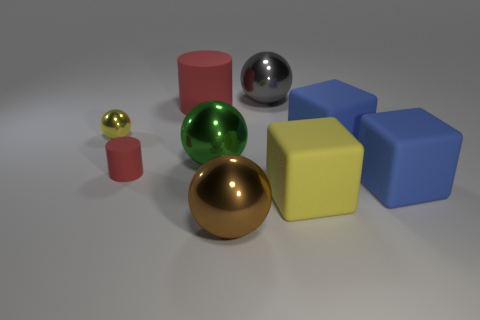What color is the matte cylinder that is the same size as the yellow matte block? red 